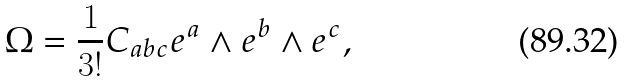Convert formula to latex. <formula><loc_0><loc_0><loc_500><loc_500>\Omega = \frac { 1 } { 3 ! } C _ { a b c } e ^ { a } \wedge e ^ { b } \wedge e ^ { c } ,</formula> 